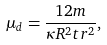<formula> <loc_0><loc_0><loc_500><loc_500>\mu _ { d } = \frac { 1 2 m } { \kappa R ^ { 2 } t r ^ { 2 } } ,</formula> 